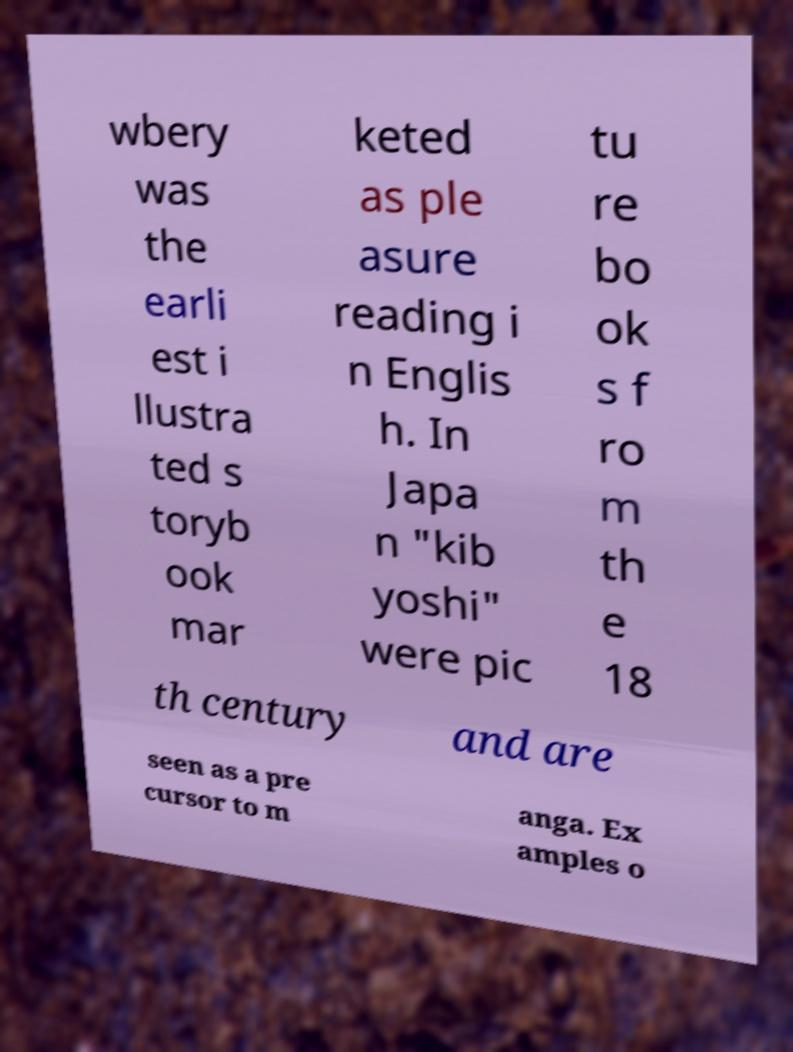Could you extract and type out the text from this image? wbery was the earli est i llustra ted s toryb ook mar keted as ple asure reading i n Englis h. In Japa n "kib yoshi" were pic tu re bo ok s f ro m th e 18 th century and are seen as a pre cursor to m anga. Ex amples o 